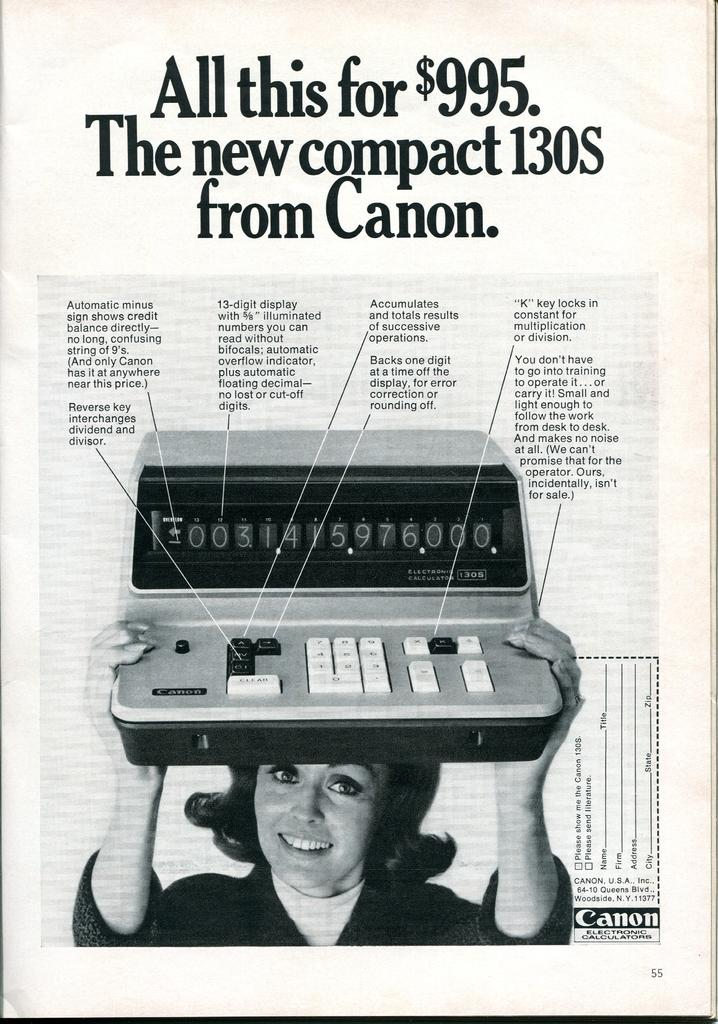What is the medium of the image? The image is on a paper. What is depicted in the image on the paper? There is an image of a woman on the paper. What is the woman holding in the image? The woman is holding an object in the image. Is there any text present on the paper? Yes, there is writing on the paper. How does the woman kick the sleet in the image? There is no sleet present in the image, and the woman is not kicking anything. 